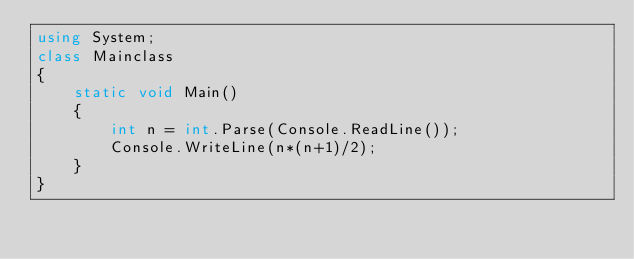Convert code to text. <code><loc_0><loc_0><loc_500><loc_500><_C#_>using System;
class Mainclass
{
    static void Main()
    {
        int n = int.Parse(Console.ReadLine());
        Console.WriteLine(n*(n+1)/2);
    }
}</code> 